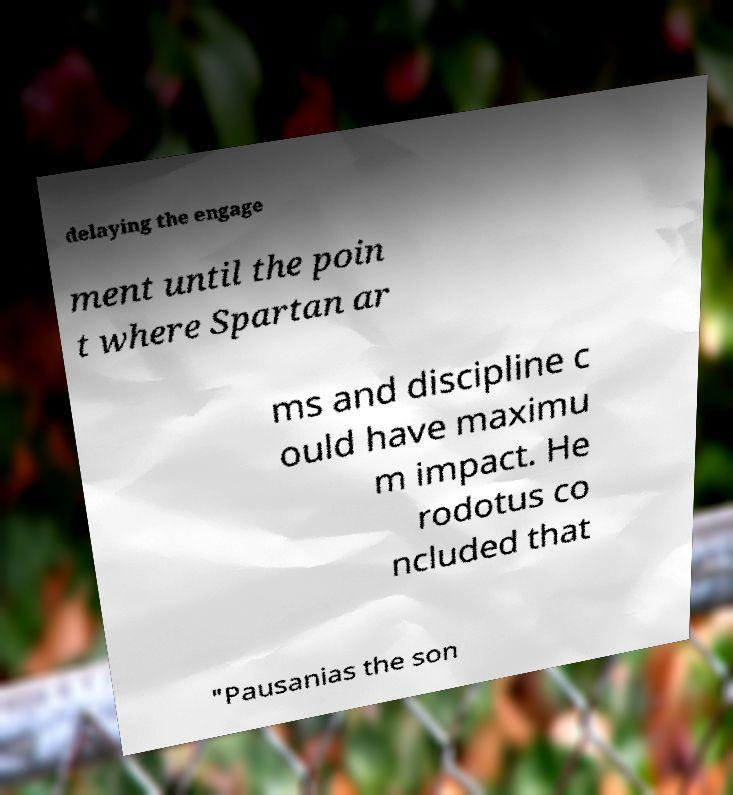Can you accurately transcribe the text from the provided image for me? delaying the engage ment until the poin t where Spartan ar ms and discipline c ould have maximu m impact. He rodotus co ncluded that "Pausanias the son 